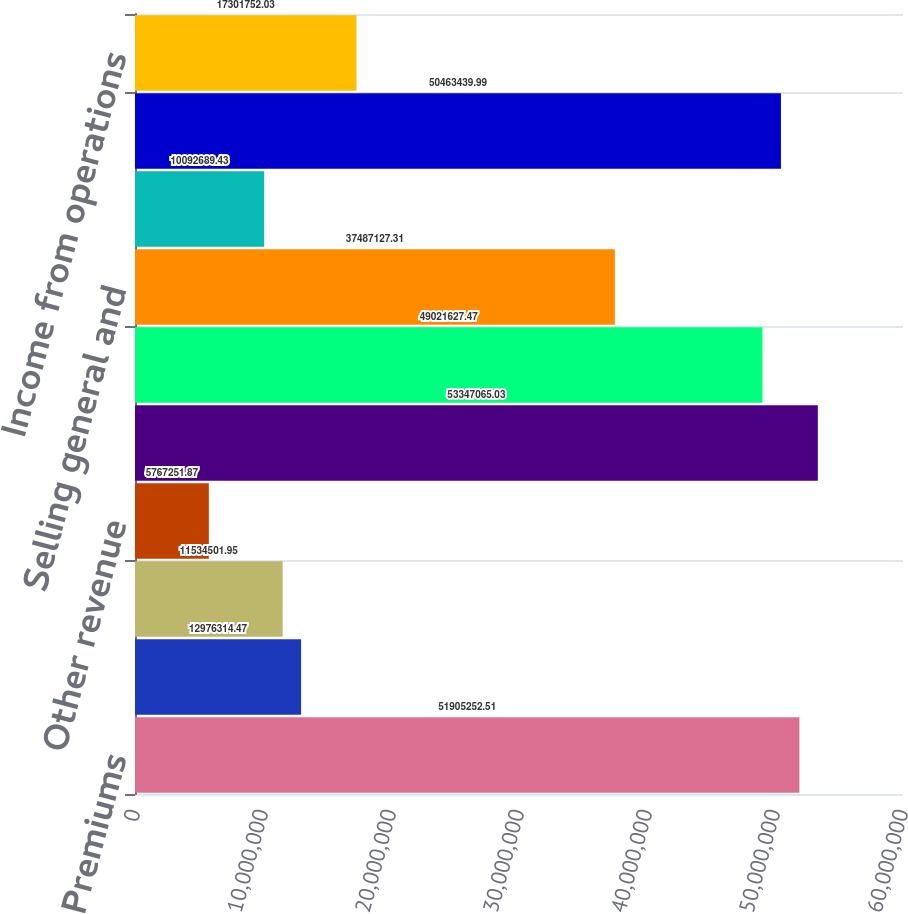Convert chart. <chart><loc_0><loc_0><loc_500><loc_500><bar_chart><fcel>Premiums<fcel>Administrative services fees<fcel>Investment income<fcel>Other revenue<fcel>Total revenues<fcel>Benefits<fcel>Selling general and<fcel>Depreciation and amortization<fcel>Total operating expenses<fcel>Income from operations<nl><fcel>5.19053e+07<fcel>1.29763e+07<fcel>1.15345e+07<fcel>5.76725e+06<fcel>5.33471e+07<fcel>4.90216e+07<fcel>3.74871e+07<fcel>1.00927e+07<fcel>5.04634e+07<fcel>1.73018e+07<nl></chart> 